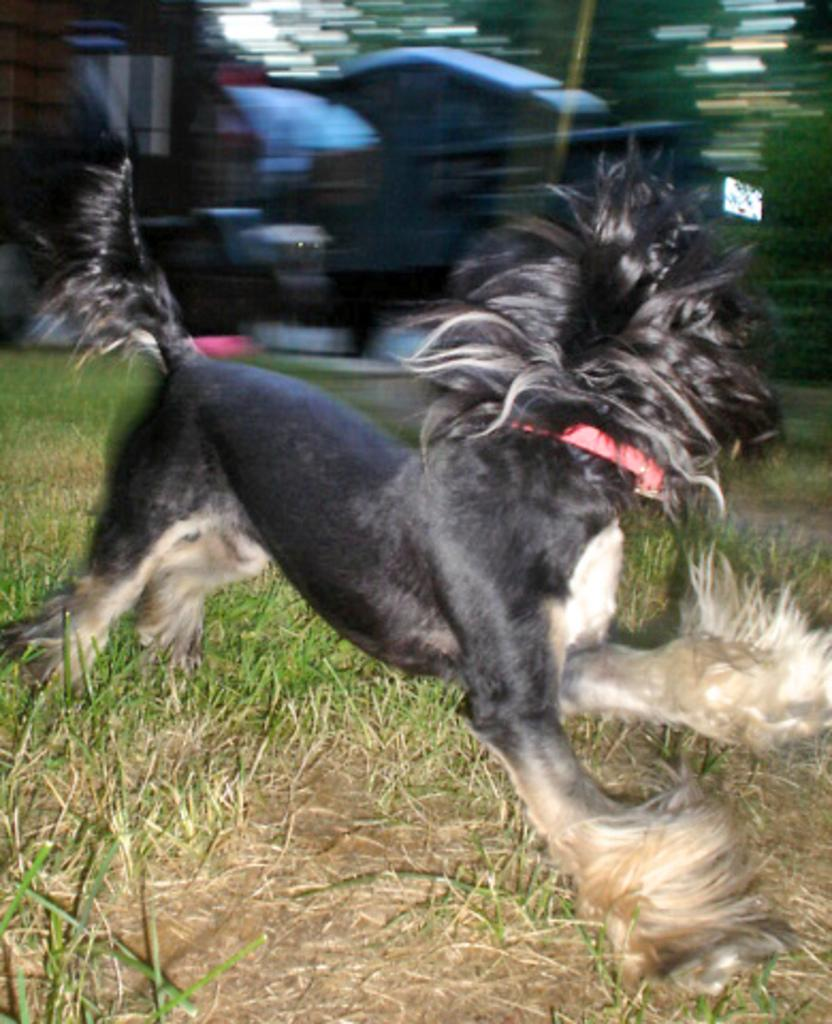What type of surface is visible on the ground in the image? There is grass on the ground in the image. What is the animal in the image doing? The animal is running in the image. Can you describe the background of the image? The background of the image is blurry. Where is the shelf located in the image? There is no shelf present in the image. What type of news can be heard in the background of the image? There is no news or audio present in the image. 